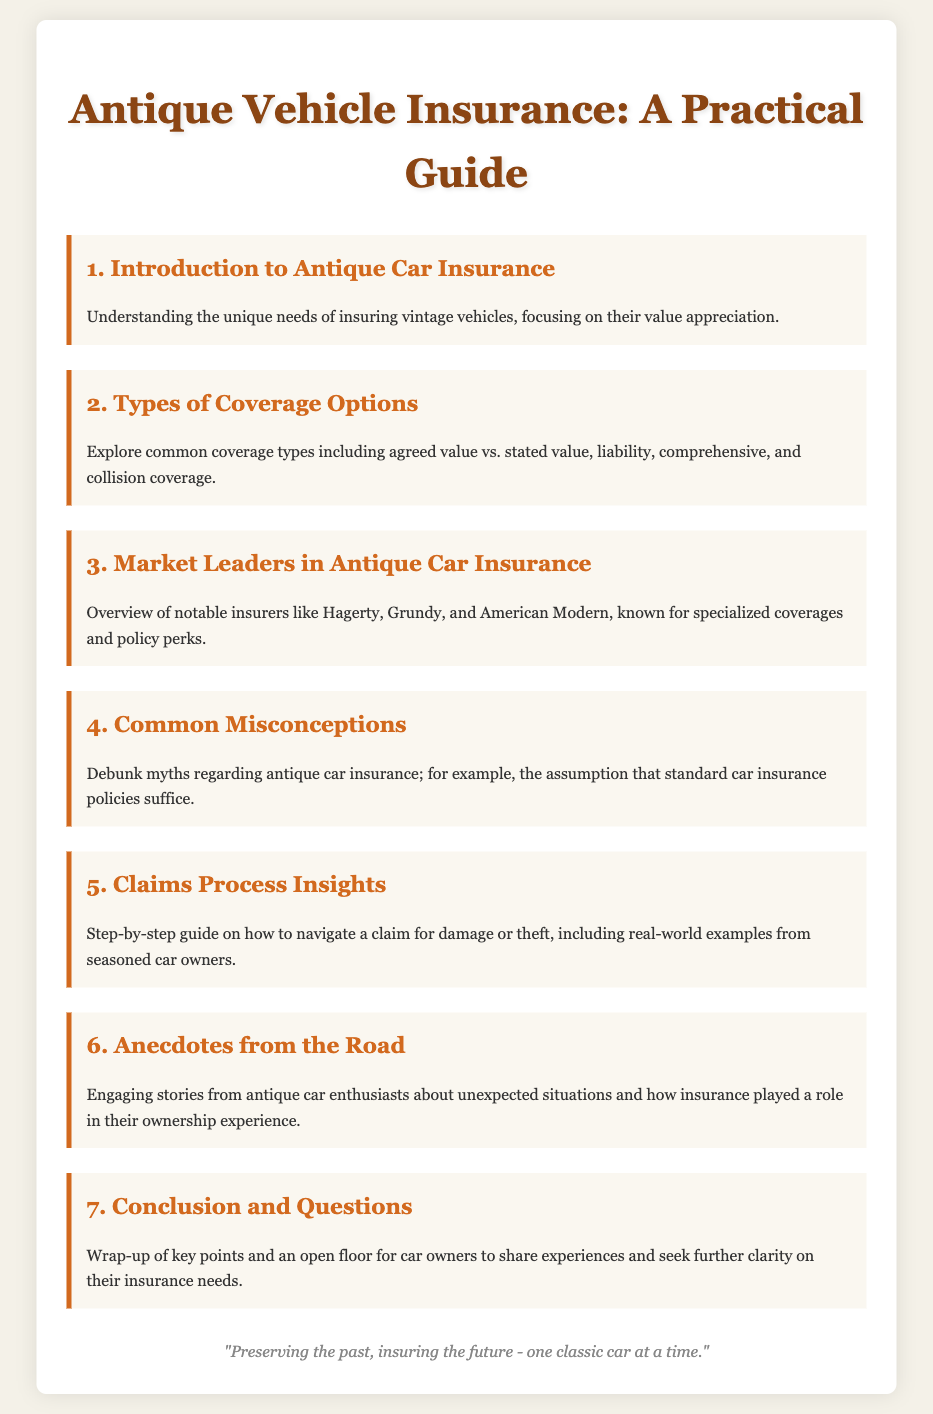what is the title of the document? The title of the document is indicated at the top of the agenda, which is "Antique Vehicle Insurance: A Practical Guide."
Answer: Antique Vehicle Insurance: A Practical Guide how many types of coverage options are listed? The document outlines a section titled "Types of Coverage Options," which implies multiple coverage options are discussed; there are four mentioned specifically in the text.
Answer: Four who are the notable insurers mentioned? The document mentions specific insurers known for their specialized coverages, which are Hagerty, Grundy, and American Modern.
Answer: Hagerty, Grundy, and American Modern what common misconception is addressed in the agenda? A section in the agenda titled "Common Misconceptions" suggests that there is an assumption about insurance policies that is commonly held, specifically regarding antique car insurance.
Answer: Standard car insurance policies suffice what is the purpose of the "Claims Process Insights" section? This section aims to provide a detailed explanation on navigating claims for damage or theft, along with examples from experienced car owners.
Answer: Step-by-step guide what quote is included at the end of the document? The footer of the document contains a quote that reflects on the significance of insuring classic cars, emphasizing preservation and future insurance.
Answer: "Preserving the past, insuring the future - one classic car at a time." 